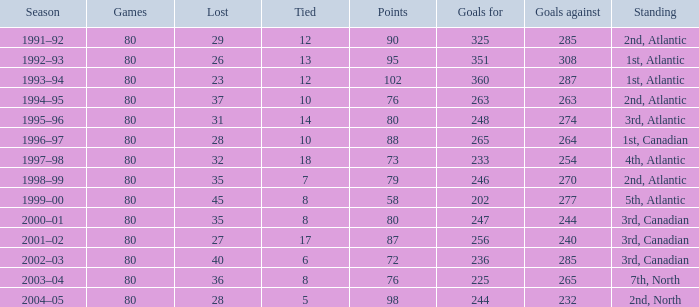How many goals against have 58 points? 277.0. 